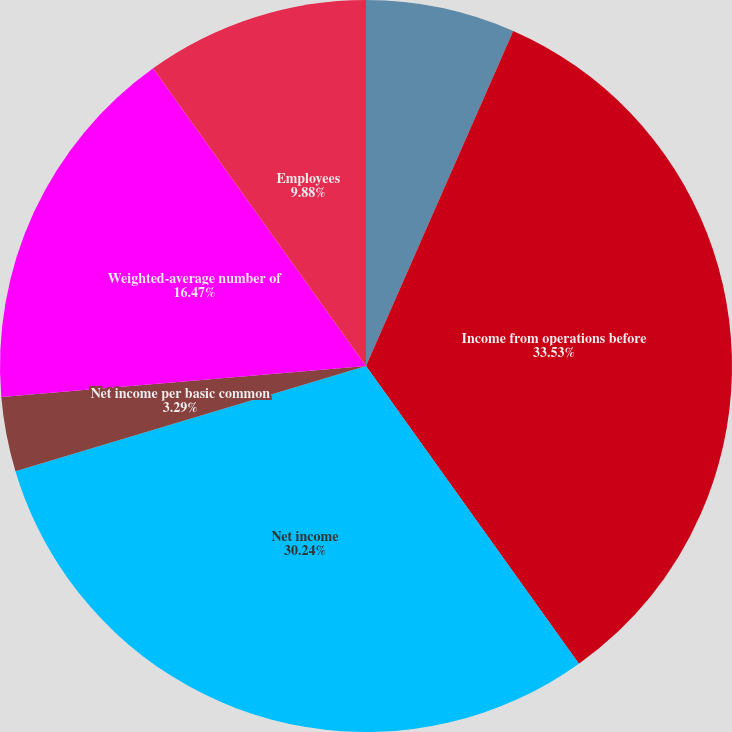<chart> <loc_0><loc_0><loc_500><loc_500><pie_chart><fcel>In thousands except per share<fcel>Income from operations before<fcel>Net income<fcel>Net income per basic common<fcel>Weighted-average number of<fcel>Net income per diluted common<fcel>Employees<nl><fcel>6.59%<fcel>33.53%<fcel>30.24%<fcel>3.29%<fcel>16.47%<fcel>0.0%<fcel>9.88%<nl></chart> 